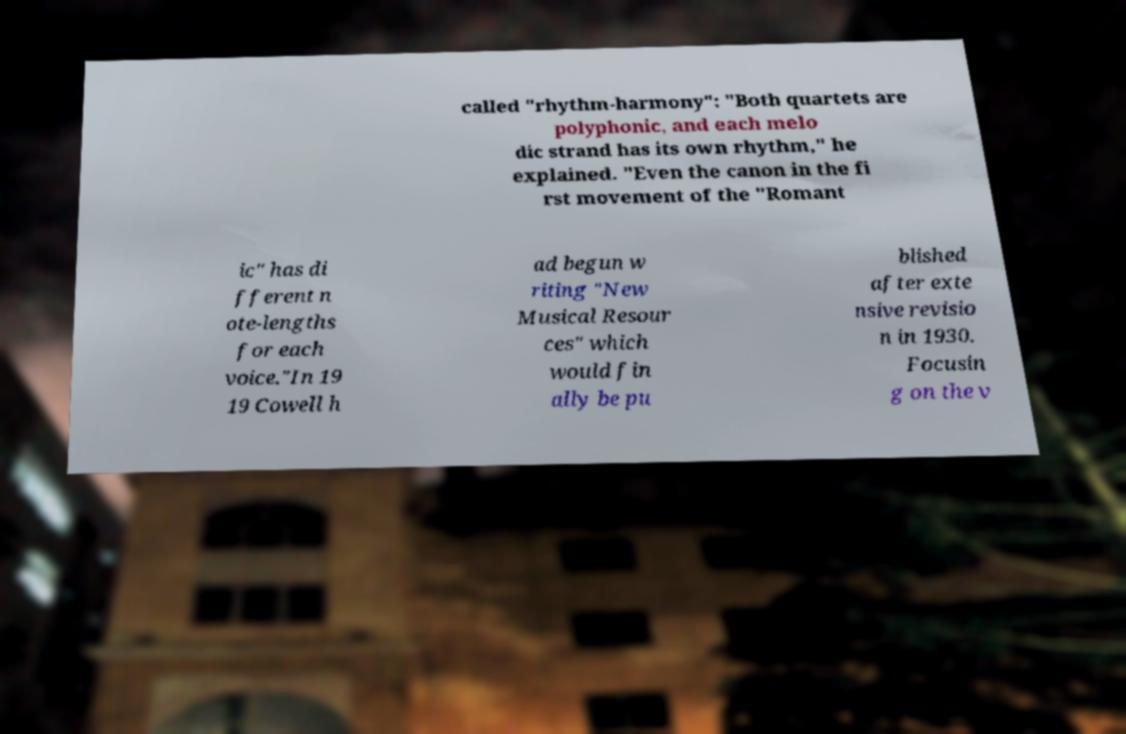I need the written content from this picture converted into text. Can you do that? called "rhythm-harmony": "Both quartets are polyphonic, and each melo dic strand has its own rhythm," he explained. "Even the canon in the fi rst movement of the "Romant ic" has di fferent n ote-lengths for each voice."In 19 19 Cowell h ad begun w riting "New Musical Resour ces" which would fin ally be pu blished after exte nsive revisio n in 1930. Focusin g on the v 